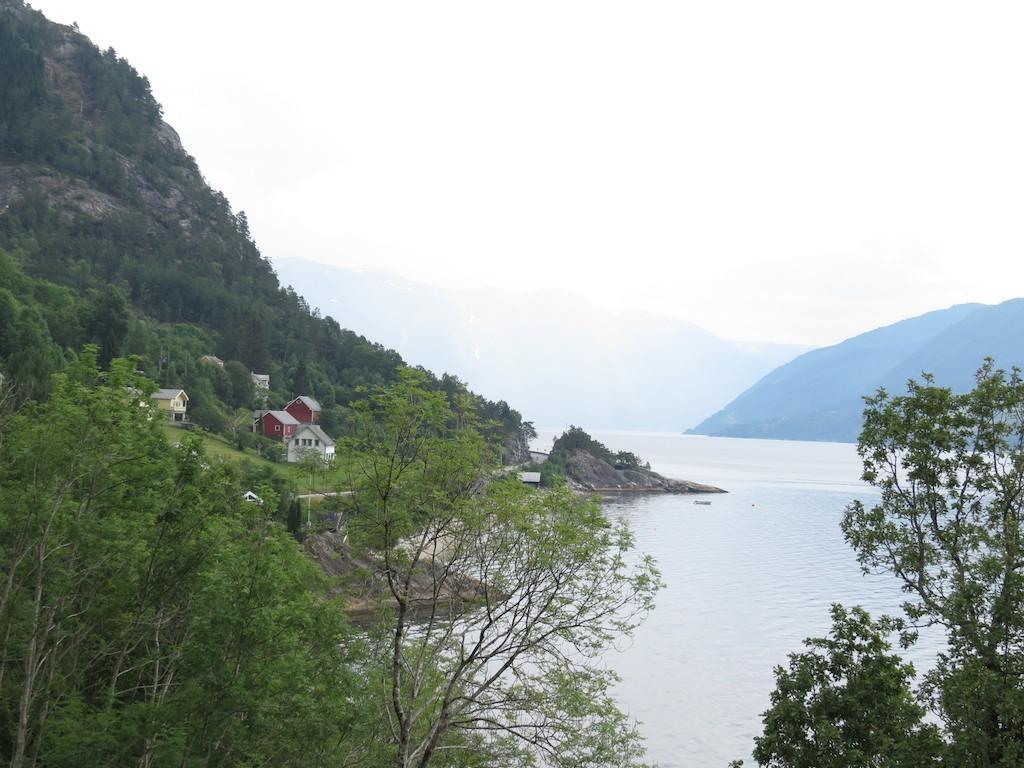Describe this image in one or two sentences. In the foreground of the picture there are trees. On the left there are houses, trees and a mountain. In the center of the picture there is a water body. On the right and in the center of the background there are hills. Sky is cloudy. 